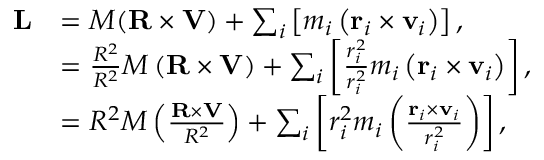<formula> <loc_0><loc_0><loc_500><loc_500>{ \begin{array} { r l } { L } & { = M ( R \times V ) + \sum _ { i } \left [ m _ { i } \left ( r _ { i } \times v _ { i } \right ) \right ] , } \\ & { = { \frac { R ^ { 2 } } { R ^ { 2 } } } M \left ( R \times V \right ) + \sum _ { i } \left [ { \frac { r _ { i } ^ { 2 } } { r _ { i } ^ { 2 } } } m _ { i } \left ( r _ { i } \times v _ { i } \right ) \right ] , } \\ & { = R ^ { 2 } M \left ( { \frac { R \times V } { R ^ { 2 } } } \right ) + \sum _ { i } \left [ r _ { i } ^ { 2 } m _ { i } \left ( { \frac { r _ { i } \times v _ { i } } { r _ { i } ^ { 2 } } } \right ) \right ] , } \end{array} }</formula> 